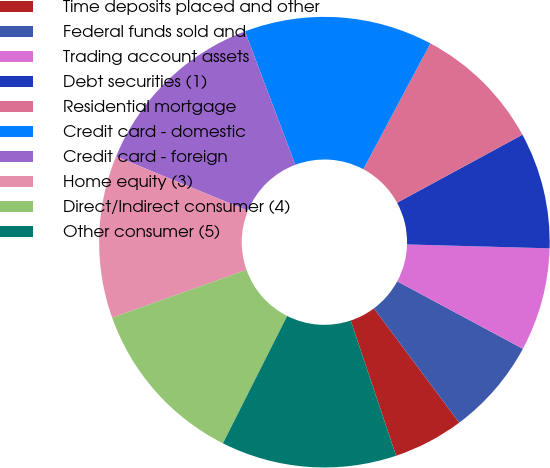Convert chart to OTSL. <chart><loc_0><loc_0><loc_500><loc_500><pie_chart><fcel>Time deposits placed and other<fcel>Federal funds sold and<fcel>Trading account assets<fcel>Debt securities (1)<fcel>Residential mortgage<fcel>Credit card - domestic<fcel>Credit card - foreign<fcel>Home equity (3)<fcel>Direct/Indirect consumer (4)<fcel>Other consumer (5)<nl><fcel>5.06%<fcel>6.94%<fcel>7.41%<fcel>8.35%<fcel>9.29%<fcel>13.53%<fcel>13.06%<fcel>11.65%<fcel>12.12%<fcel>12.59%<nl></chart> 